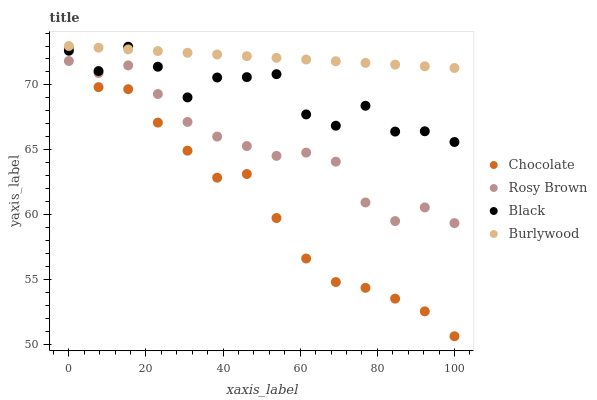Does Chocolate have the minimum area under the curve?
Answer yes or no. Yes. Does Burlywood have the maximum area under the curve?
Answer yes or no. Yes. Does Rosy Brown have the minimum area under the curve?
Answer yes or no. No. Does Rosy Brown have the maximum area under the curve?
Answer yes or no. No. Is Burlywood the smoothest?
Answer yes or no. Yes. Is Black the roughest?
Answer yes or no. Yes. Is Rosy Brown the smoothest?
Answer yes or no. No. Is Rosy Brown the roughest?
Answer yes or no. No. Does Chocolate have the lowest value?
Answer yes or no. Yes. Does Rosy Brown have the lowest value?
Answer yes or no. No. Does Burlywood have the highest value?
Answer yes or no. Yes. Does Black have the highest value?
Answer yes or no. No. Is Rosy Brown less than Burlywood?
Answer yes or no. Yes. Is Black greater than Rosy Brown?
Answer yes or no. Yes. Does Black intersect Chocolate?
Answer yes or no. Yes. Is Black less than Chocolate?
Answer yes or no. No. Is Black greater than Chocolate?
Answer yes or no. No. Does Rosy Brown intersect Burlywood?
Answer yes or no. No. 